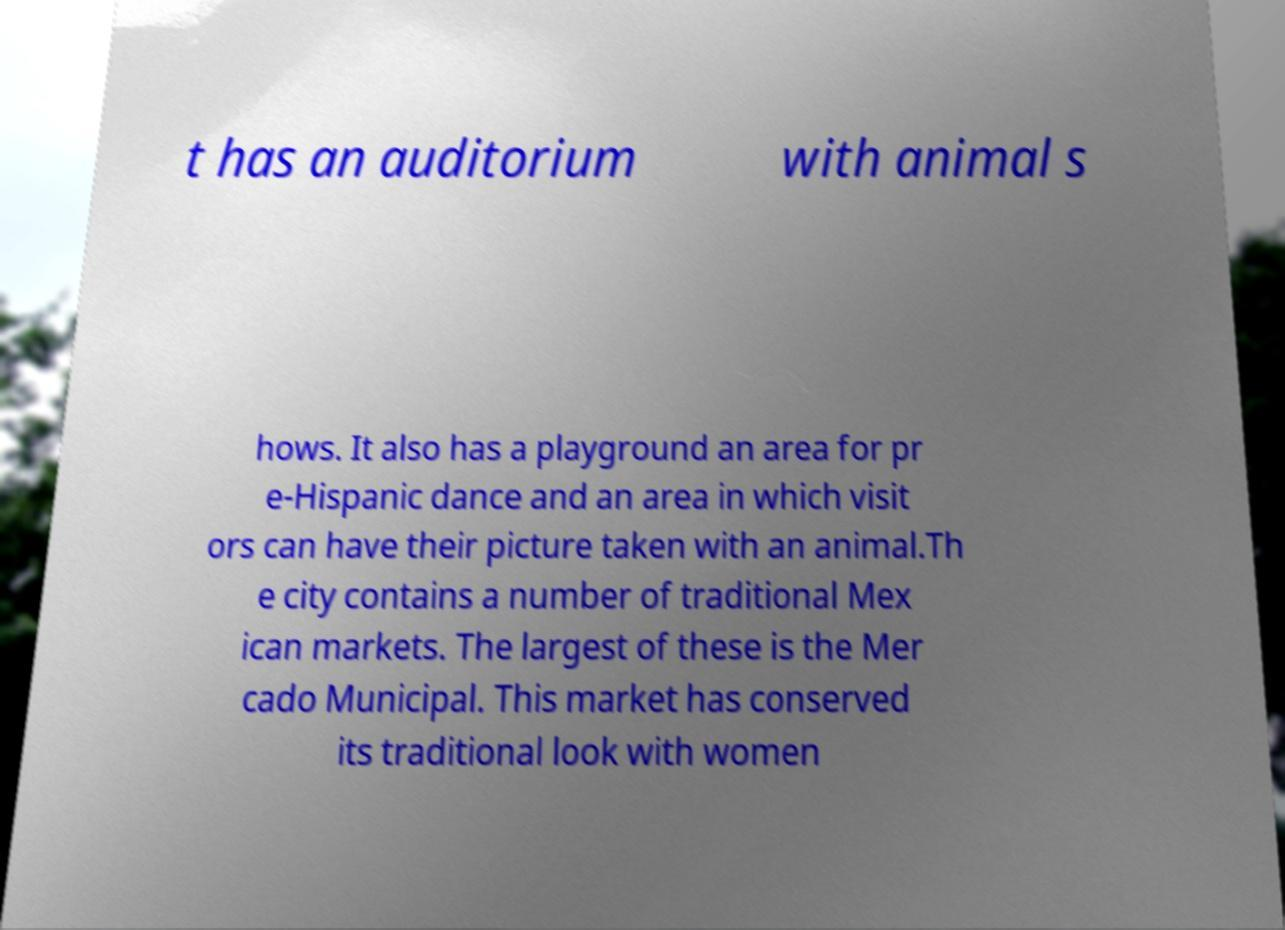Can you accurately transcribe the text from the provided image for me? t has an auditorium with animal s hows. It also has a playground an area for pr e-Hispanic dance and an area in which visit ors can have their picture taken with an animal.Th e city contains a number of traditional Mex ican markets. The largest of these is the Mer cado Municipal. This market has conserved its traditional look with women 